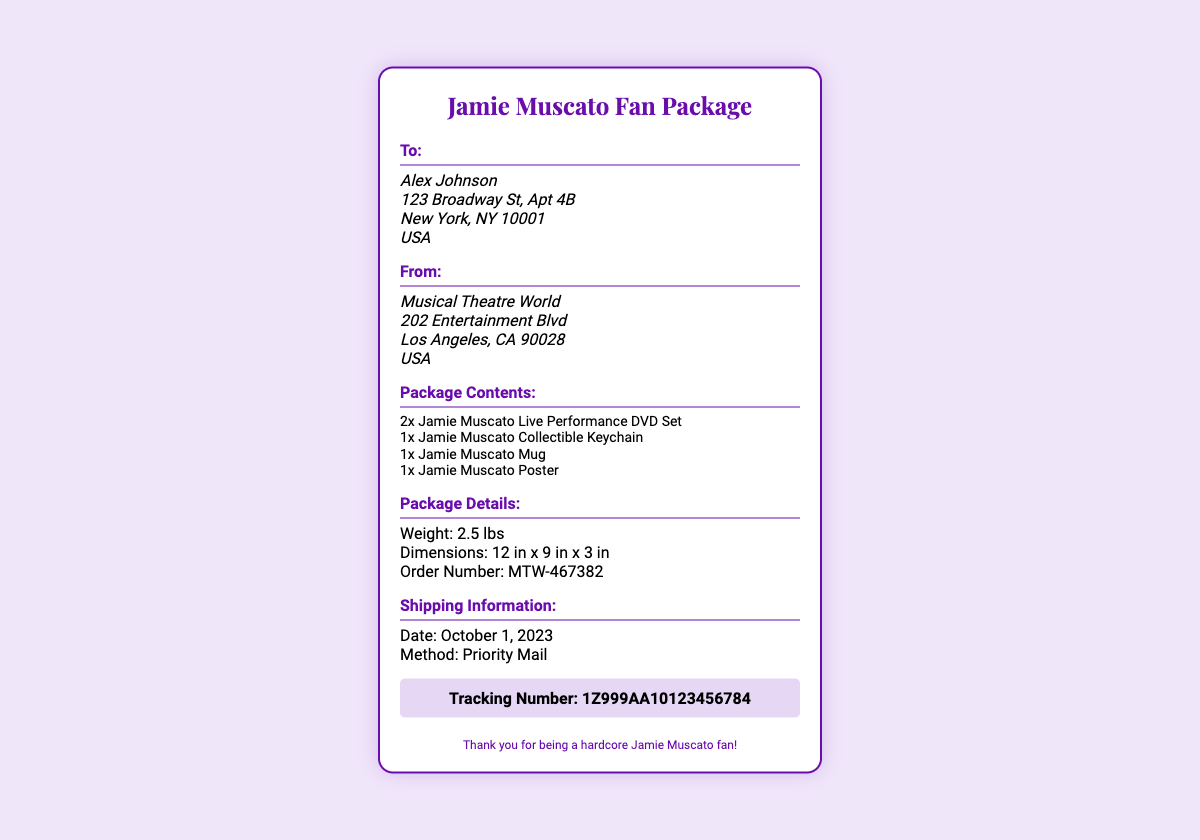what is the recipient's name? The shipping label shows that the package is addressed to Alex Johnson.
Answer: Alex Johnson how many DVDs are included in the package? The document states that there are 2 Jamie Muscato Live Performance DVD Sets included.
Answer: 2 what is the order number? The order number is provided in the package details section.
Answer: MTW-467382 what is the shipping date? The shipping information section specifies the date as October 1, 2023.
Answer: October 1, 2023 what type of merchandise is included in the package? The package contents specify collectible items, including a keychain, mug, and poster.
Answer: Keychain, Mug, Poster how heavy is the package? The weight of the package is mentioned directly in the package details.
Answer: 2.5 lbs who is the sender of the package? The document indicates that the package is sent from Musical Theatre World.
Answer: Musical Theatre World what shipping method is used? The shipping information states that the package is sent via Priority Mail.
Answer: Priority Mail what is the tracking number? The tracking number is displayed prominently in the tracking section of the document.
Answer: 1Z999AA10123456784 